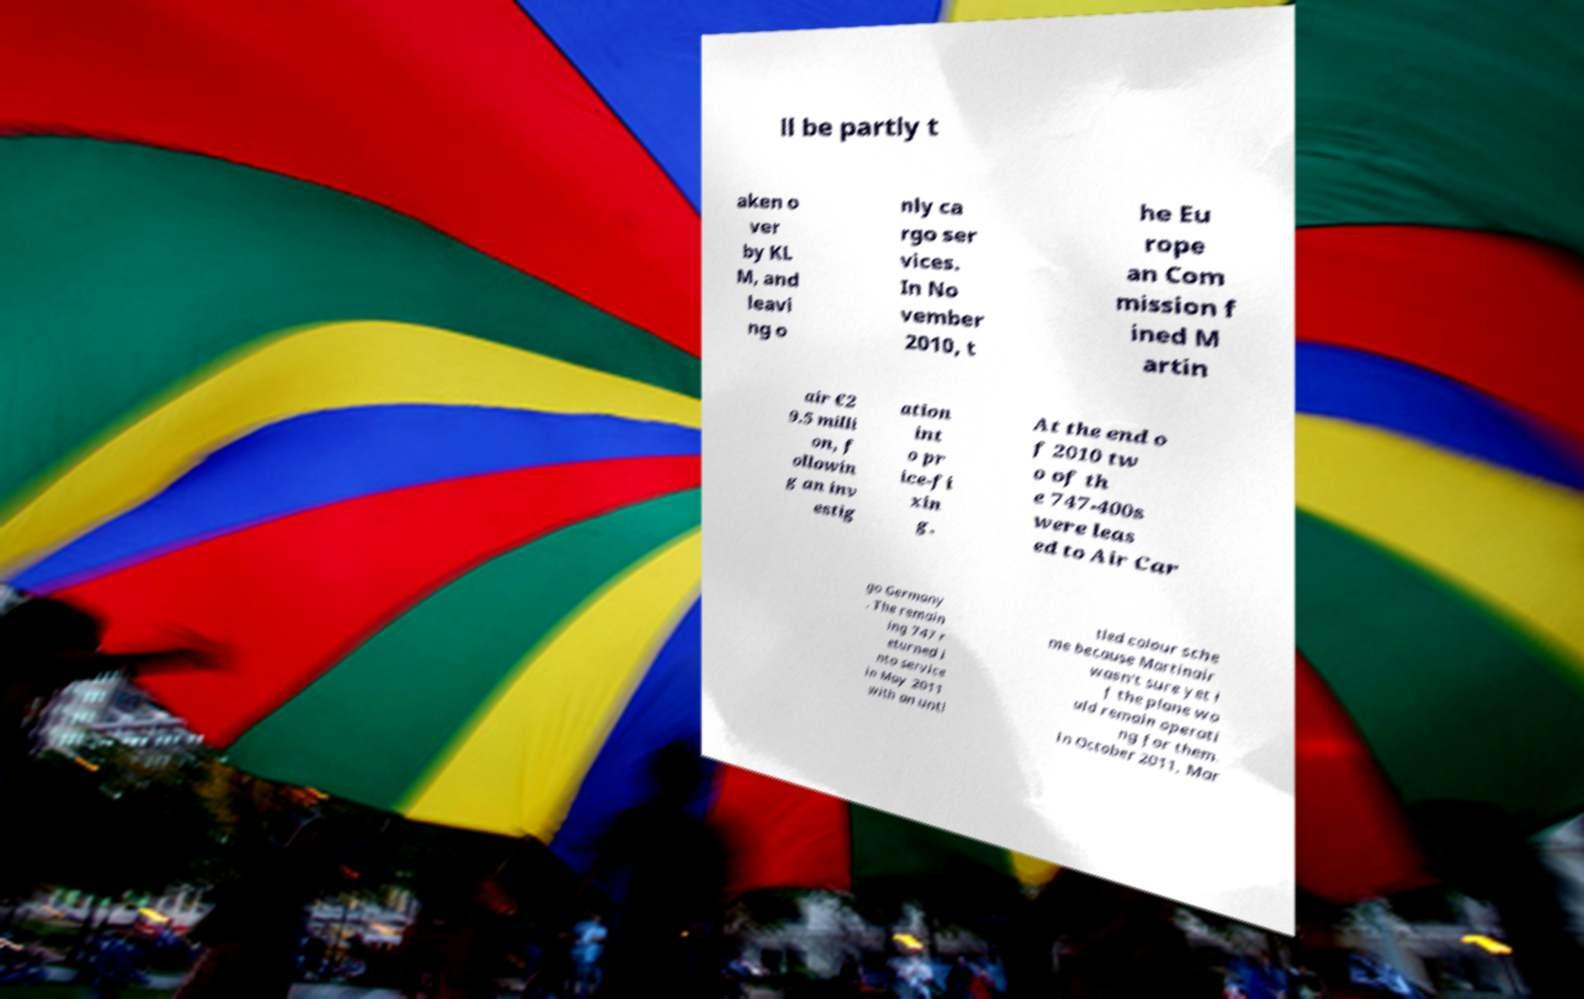Can you accurately transcribe the text from the provided image for me? ll be partly t aken o ver by KL M, and leavi ng o nly ca rgo ser vices. In No vember 2010, t he Eu rope an Com mission f ined M artin air €2 9.5 milli on, f ollowin g an inv estig ation int o pr ice-fi xin g. At the end o f 2010 tw o of th e 747-400s were leas ed to Air Car go Germany . The remain ing 747 r eturned i nto service in May 2011 with an unti tled colour sche me because Martinair wasn't sure yet i f the plane wo uld remain operati ng for them. In October 2011, Mar 